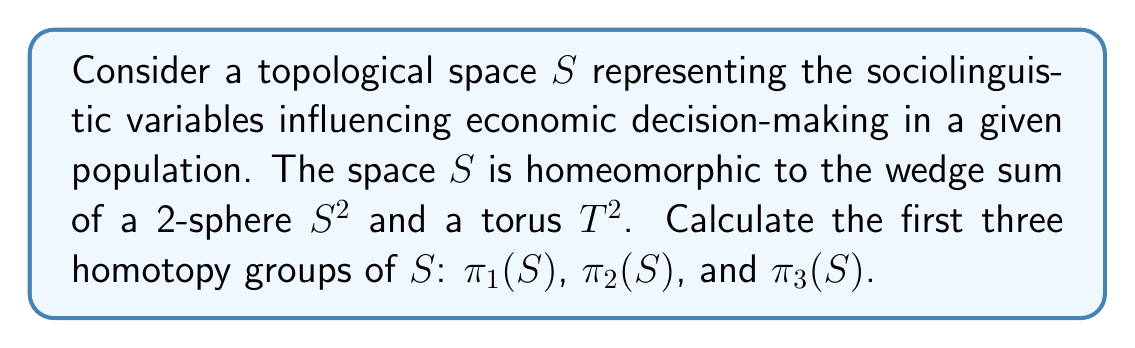Provide a solution to this math problem. To solve this problem, we'll use the properties of homotopy groups and the given information about the space $S$. Let's proceed step by step:

1) First, recall that $S$ is homeomorphic to $S^2 \vee T^2$ (the wedge sum of a 2-sphere and a torus).

2) For the first homotopy group $\pi_1(S)$:
   - $\pi_1(S^2) = 0$ (the 2-sphere is simply connected)
   - $\pi_1(T^2) = \mathbb{Z} \times \mathbb{Z}$ (the fundamental group of a torus is the product of two infinite cyclic groups)
   - For a wedge sum, $\pi_1(X \vee Y) \cong \pi_1(X) * \pi_1(Y)$ (free product)
   Therefore, $\pi_1(S) \cong 0 * (\mathbb{Z} \times \mathbb{Z}) \cong \mathbb{Z} \times \mathbb{Z}$

3) For the second homotopy group $\pi_2(S)$:
   - $\pi_2(S^2) = \mathbb{Z}$
   - $\pi_2(T^2) = 0$ (the universal cover of a torus is contractible)
   - For a wedge sum, $\pi_2(X \vee Y) \cong \pi_2(X) \oplus \pi_2(Y)$ when $X$ and $Y$ are path-connected
   Therefore, $\pi_2(S) \cong \mathbb{Z} \oplus 0 \cong \mathbb{Z}$

4) For the third homotopy group $\pi_3(S)$:
   - $\pi_3(S^2) = \mathbb{Z}$ (by the Hopf fibration)
   - $\pi_3(T^2) = 0$ (higher homotopy groups of the torus are trivial)
   - Again, $\pi_3(X \vee Y) \cong \pi_3(X) \oplus \pi_3(Y)$ for path-connected spaces
   Therefore, $\pi_3(S) \cong \mathbb{Z} \oplus 0 \cong \mathbb{Z}$
Answer: $\pi_1(S) \cong \mathbb{Z} \times \mathbb{Z}$, $\pi_2(S) \cong \mathbb{Z}$, $\pi_3(S) \cong \mathbb{Z}$ 